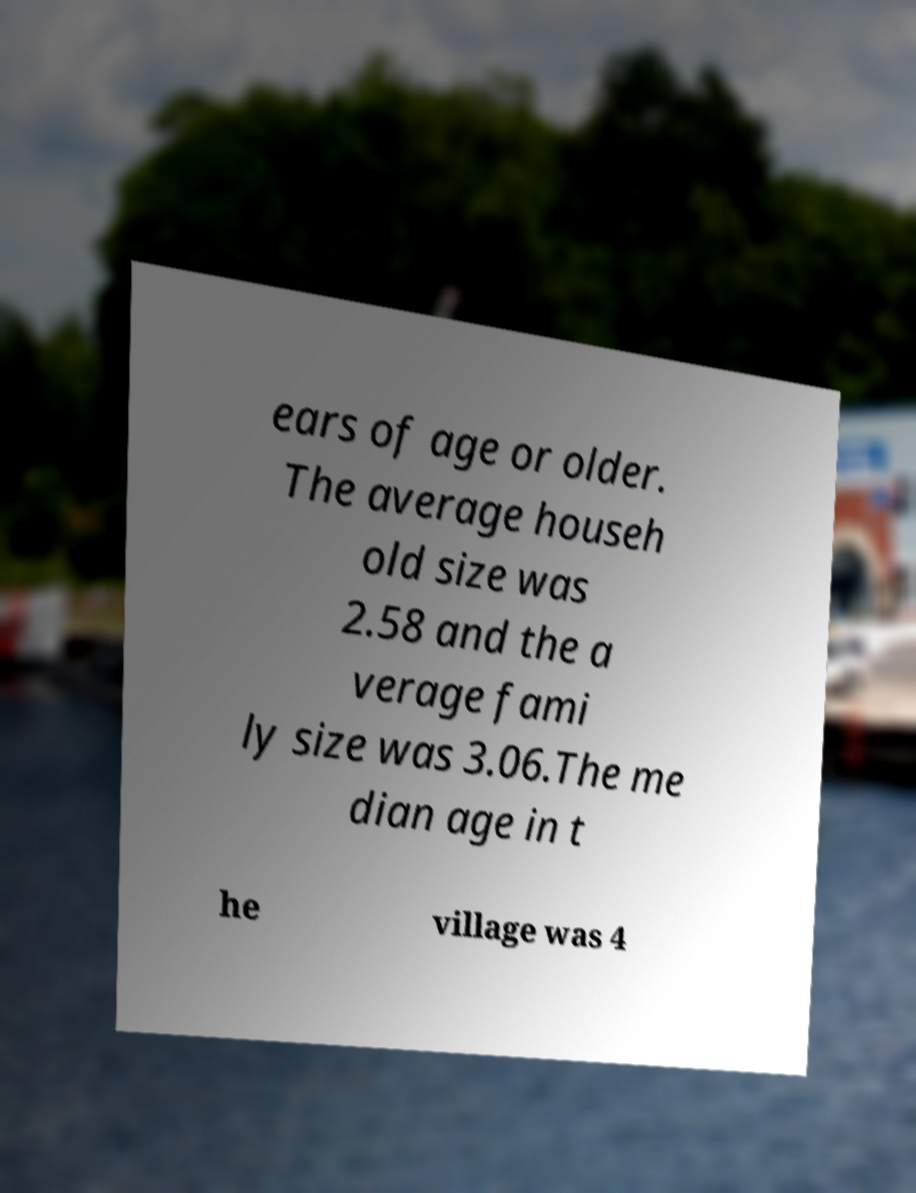Could you assist in decoding the text presented in this image and type it out clearly? ears of age or older. The average househ old size was 2.58 and the a verage fami ly size was 3.06.The me dian age in t he village was 4 